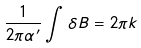<formula> <loc_0><loc_0><loc_500><loc_500>\frac { 1 } { 2 \pi \alpha ^ { \prime } } \int \delta B = 2 \pi k</formula> 